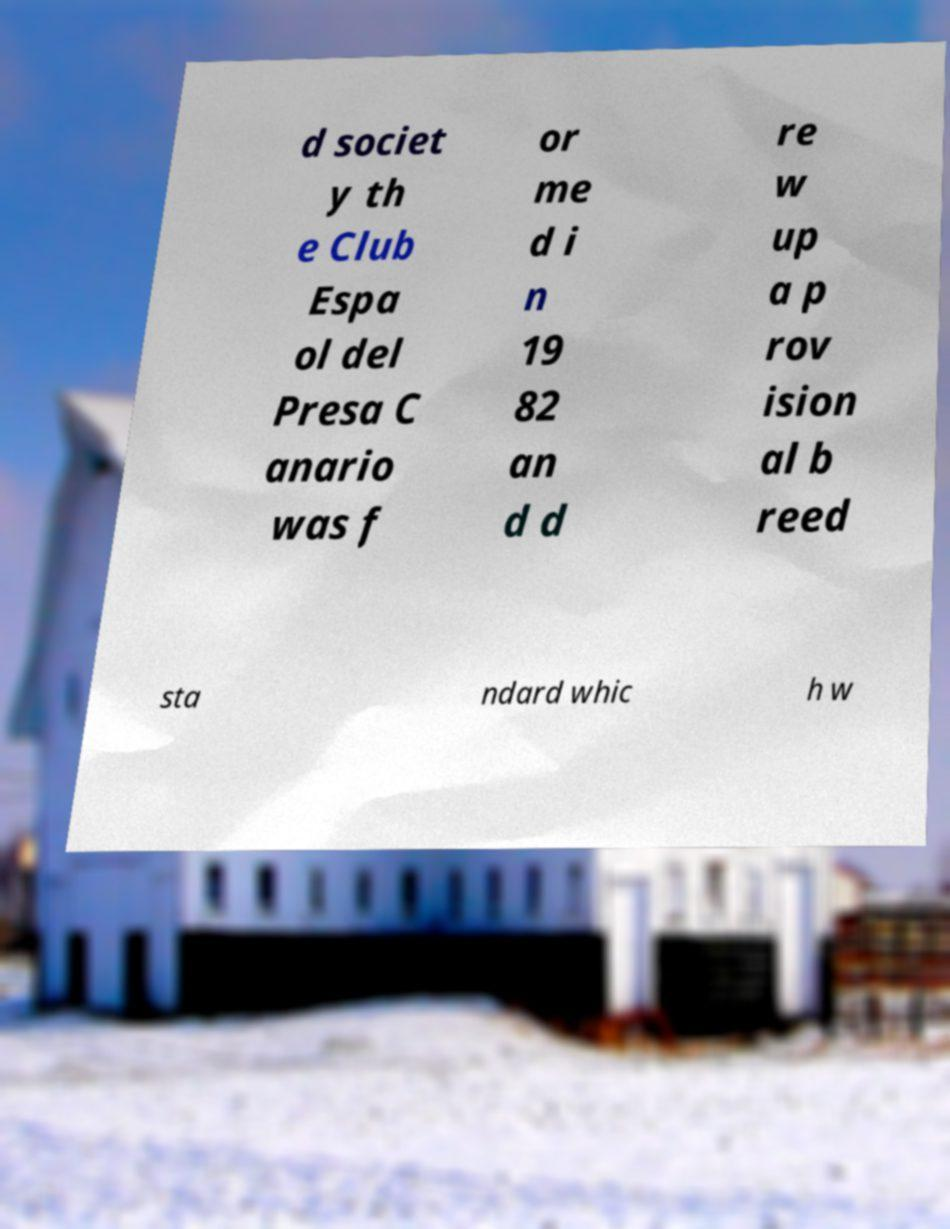For documentation purposes, I need the text within this image transcribed. Could you provide that? d societ y th e Club Espa ol del Presa C anario was f or me d i n 19 82 an d d re w up a p rov ision al b reed sta ndard whic h w 